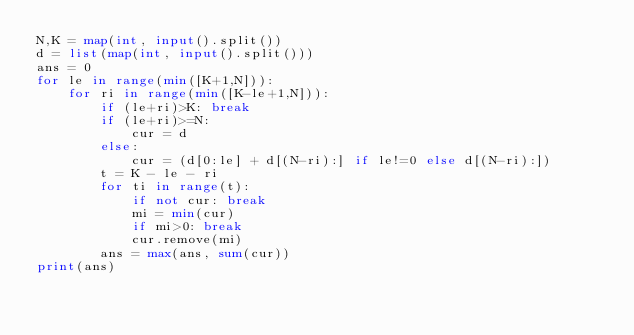<code> <loc_0><loc_0><loc_500><loc_500><_Python_>N,K = map(int, input().split())
d = list(map(int, input().split()))
ans = 0
for le in range(min([K+1,N])):
    for ri in range(min([K-le+1,N])):
        if (le+ri)>K: break
        if (le+ri)>=N:
            cur = d
        else:
            cur = (d[0:le] + d[(N-ri):] if le!=0 else d[(N-ri):])
        t = K - le - ri
        for ti in range(t):
            if not cur: break
            mi = min(cur)
            if mi>0: break
            cur.remove(mi)
        ans = max(ans, sum(cur))
print(ans)</code> 